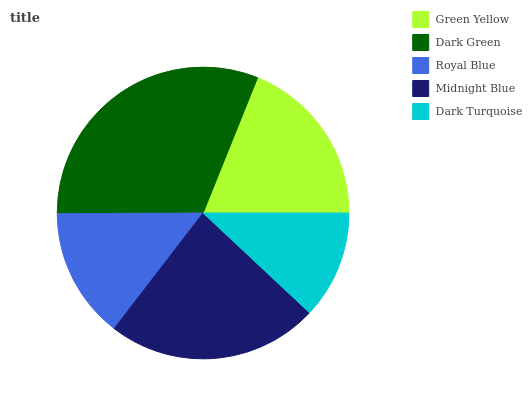Is Dark Turquoise the minimum?
Answer yes or no. Yes. Is Dark Green the maximum?
Answer yes or no. Yes. Is Royal Blue the minimum?
Answer yes or no. No. Is Royal Blue the maximum?
Answer yes or no. No. Is Dark Green greater than Royal Blue?
Answer yes or no. Yes. Is Royal Blue less than Dark Green?
Answer yes or no. Yes. Is Royal Blue greater than Dark Green?
Answer yes or no. No. Is Dark Green less than Royal Blue?
Answer yes or no. No. Is Green Yellow the high median?
Answer yes or no. Yes. Is Green Yellow the low median?
Answer yes or no. Yes. Is Royal Blue the high median?
Answer yes or no. No. Is Midnight Blue the low median?
Answer yes or no. No. 